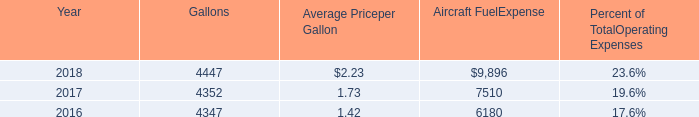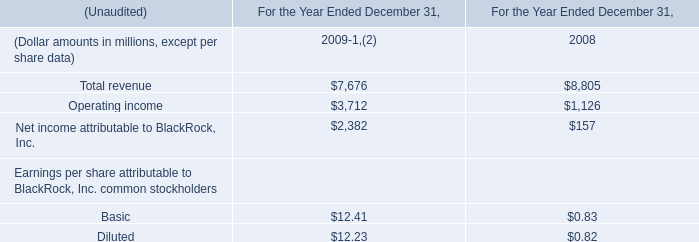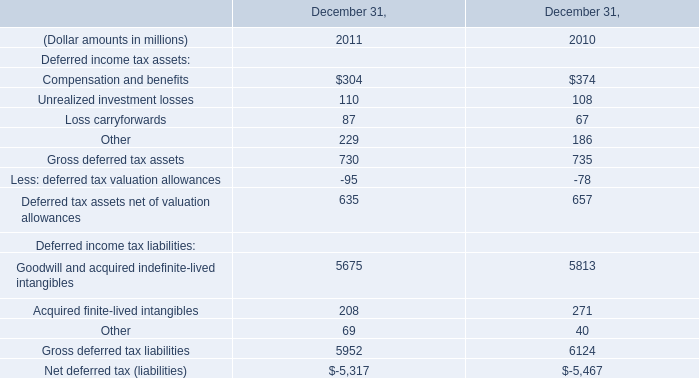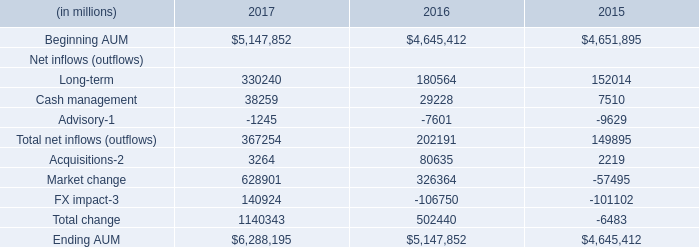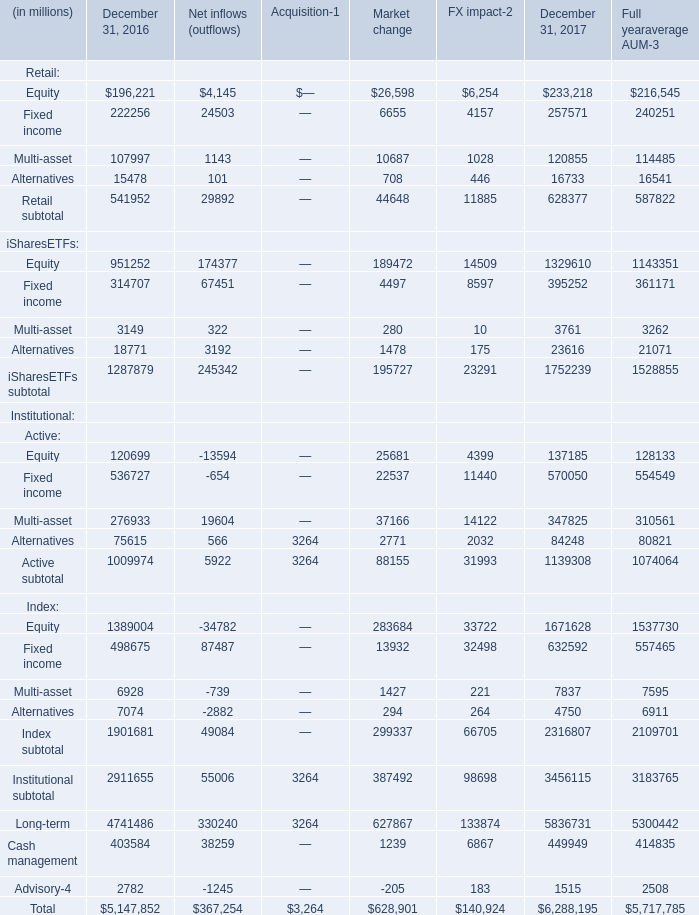How many change exceed the average of Total change in 2017? 
Answer: 1. 